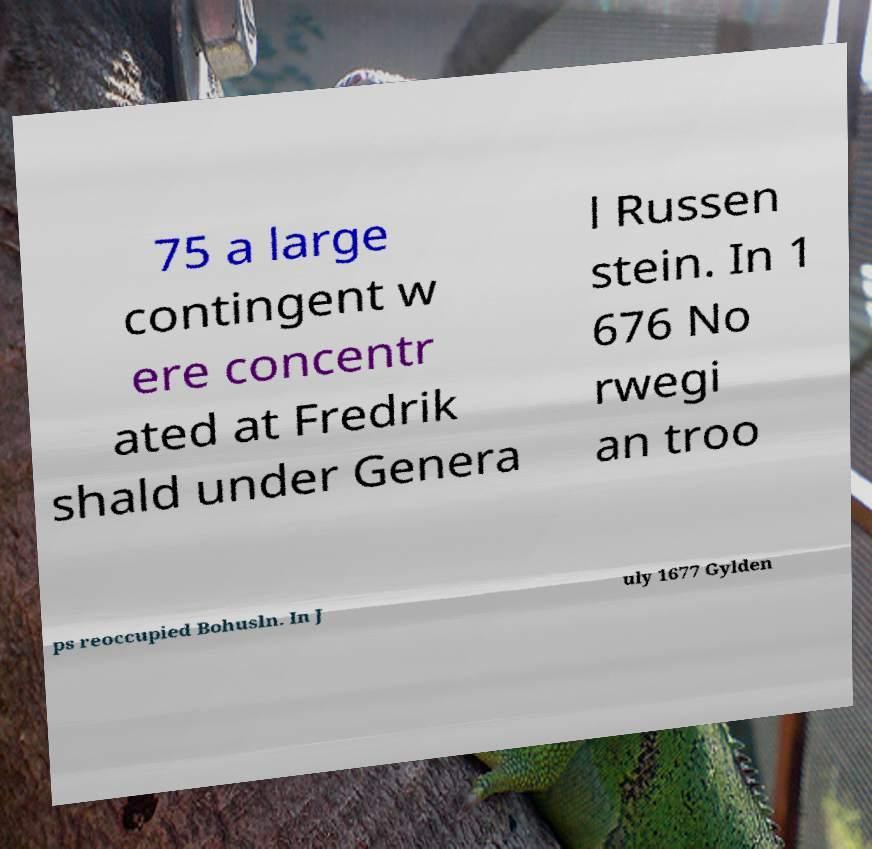Could you assist in decoding the text presented in this image and type it out clearly? 75 a large contingent w ere concentr ated at Fredrik shald under Genera l Russen stein. In 1 676 No rwegi an troo ps reoccupied Bohusln. In J uly 1677 Gylden 